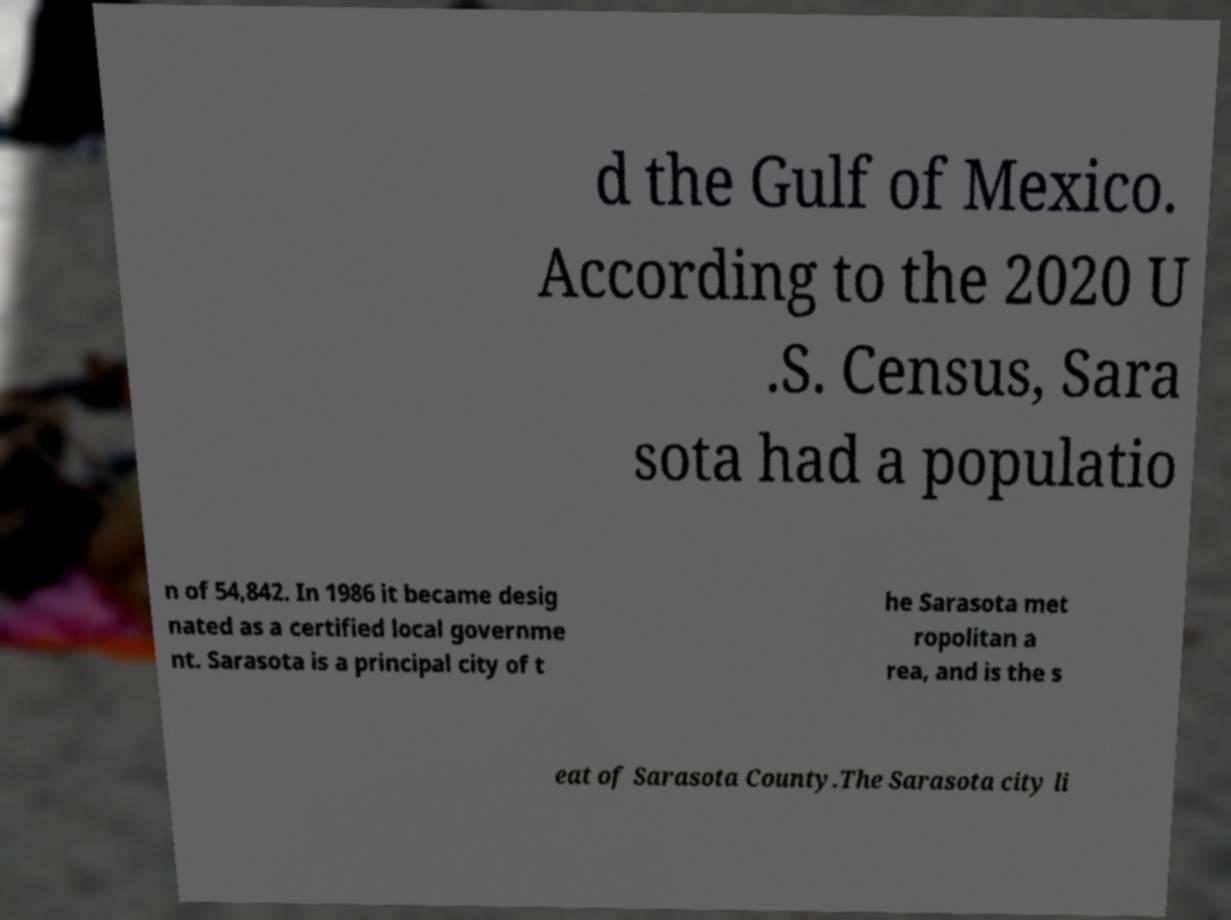Can you read and provide the text displayed in the image?This photo seems to have some interesting text. Can you extract and type it out for me? d the Gulf of Mexico. According to the 2020 U .S. Census, Sara sota had a populatio n of 54,842. In 1986 it became desig nated as a certified local governme nt. Sarasota is a principal city of t he Sarasota met ropolitan a rea, and is the s eat of Sarasota County.The Sarasota city li 